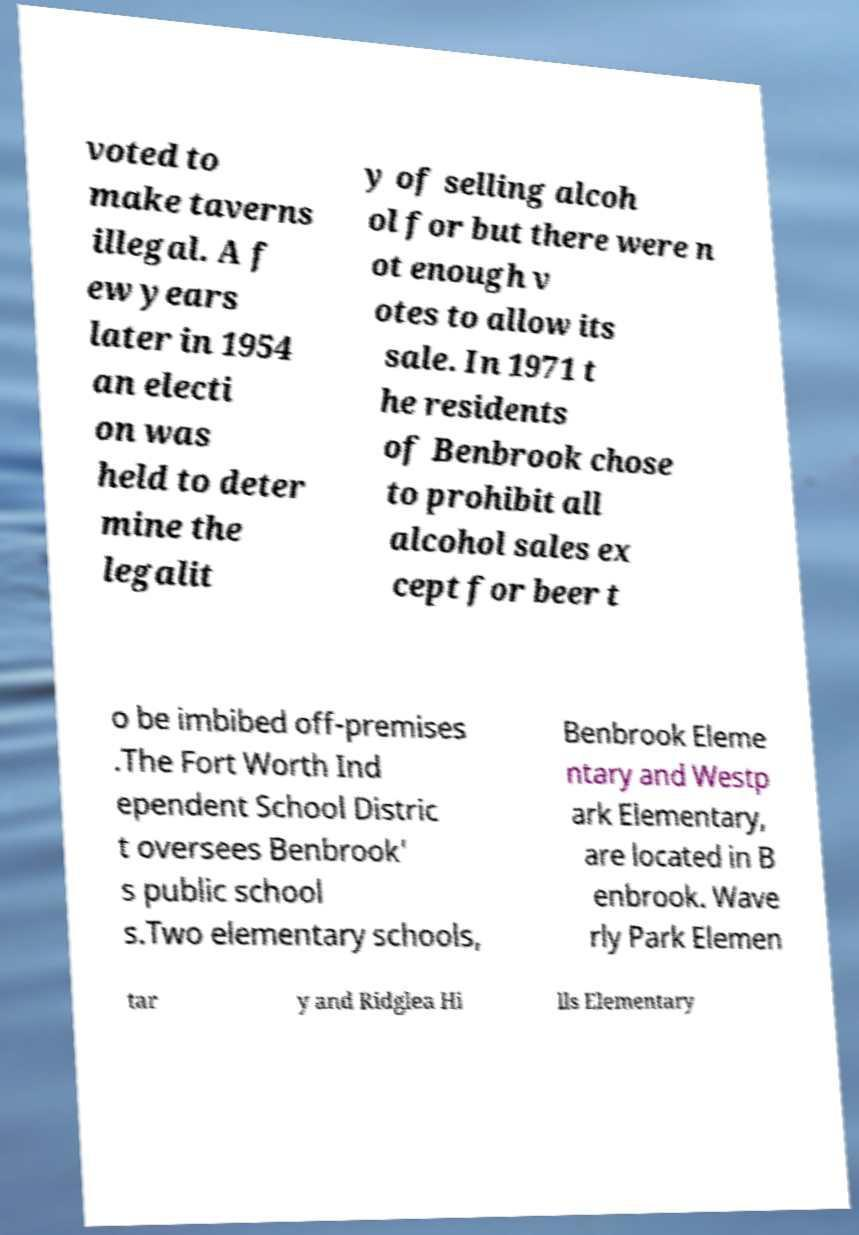Can you read and provide the text displayed in the image?This photo seems to have some interesting text. Can you extract and type it out for me? voted to make taverns illegal. A f ew years later in 1954 an electi on was held to deter mine the legalit y of selling alcoh ol for but there were n ot enough v otes to allow its sale. In 1971 t he residents of Benbrook chose to prohibit all alcohol sales ex cept for beer t o be imbibed off-premises .The Fort Worth Ind ependent School Distric t oversees Benbrook' s public school s.Two elementary schools, Benbrook Eleme ntary and Westp ark Elementary, are located in B enbrook. Wave rly Park Elemen tar y and Ridglea Hi lls Elementary 